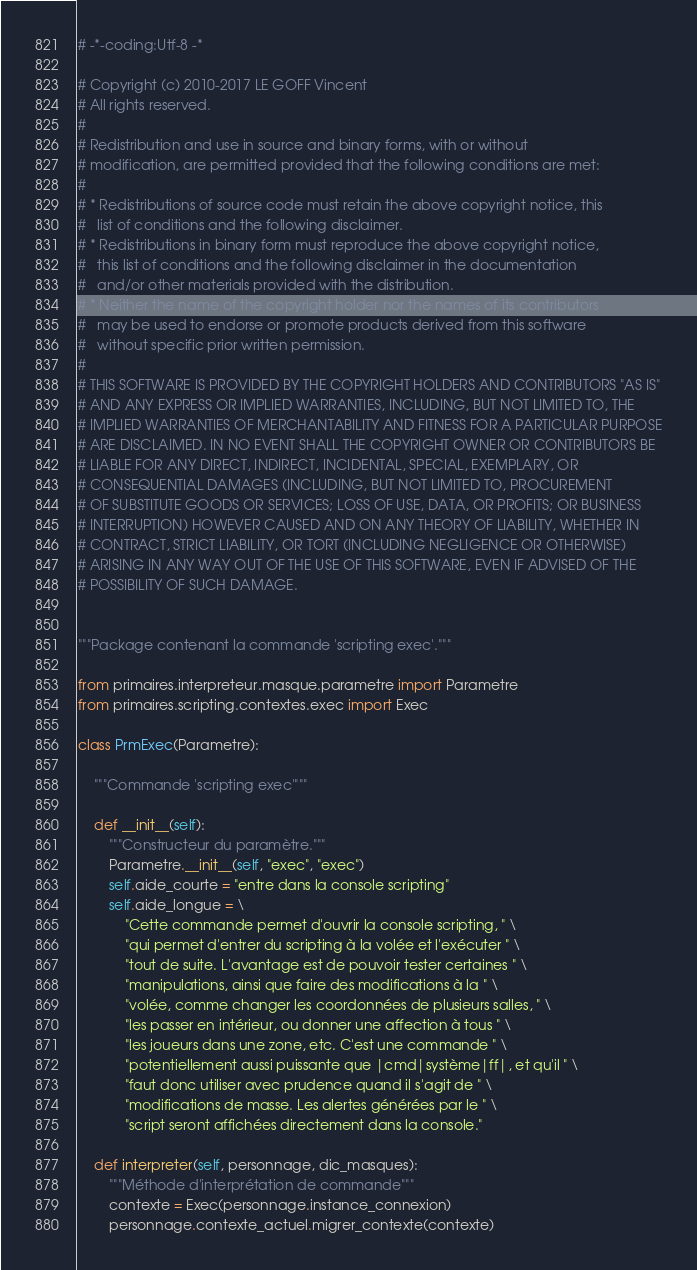<code> <loc_0><loc_0><loc_500><loc_500><_Python_># -*-coding:Utf-8 -*

# Copyright (c) 2010-2017 LE GOFF Vincent
# All rights reserved.
#
# Redistribution and use in source and binary forms, with or without
# modification, are permitted provided that the following conditions are met:
#
# * Redistributions of source code must retain the above copyright notice, this
#   list of conditions and the following disclaimer.
# * Redistributions in binary form must reproduce the above copyright notice,
#   this list of conditions and the following disclaimer in the documentation
#   and/or other materials provided with the distribution.
# * Neither the name of the copyright holder nor the names of its contributors
#   may be used to endorse or promote products derived from this software
#   without specific prior written permission.
#
# THIS SOFTWARE IS PROVIDED BY THE COPYRIGHT HOLDERS AND CONTRIBUTORS "AS IS"
# AND ANY EXPRESS OR IMPLIED WARRANTIES, INCLUDING, BUT NOT LIMITED TO, THE
# IMPLIED WARRANTIES OF MERCHANTABILITY AND FITNESS FOR A PARTICULAR PURPOSE
# ARE DISCLAIMED. IN NO EVENT SHALL THE COPYRIGHT OWNER OR CONTRIBUTORS BE
# LIABLE FOR ANY DIRECT, INDIRECT, INCIDENTAL, SPECIAL, EXEMPLARY, OR
# CONSEQUENTIAL DAMAGES (INCLUDING, BUT NOT LIMITED TO, PROCUREMENT
# OF SUBSTITUTE GOODS OR SERVICES; LOSS OF USE, DATA, OR PROFITS; OR BUSINESS
# INTERRUPTION) HOWEVER CAUSED AND ON ANY THEORY OF LIABILITY, WHETHER IN
# CONTRACT, STRICT LIABILITY, OR TORT (INCLUDING NEGLIGENCE OR OTHERWISE)
# ARISING IN ANY WAY OUT OF THE USE OF THIS SOFTWARE, EVEN IF ADVISED OF THE
# POSSIBILITY OF SUCH DAMAGE.


"""Package contenant la commande 'scripting exec'."""

from primaires.interpreteur.masque.parametre import Parametre
from primaires.scripting.contextes.exec import Exec

class PrmExec(Parametre):

    """Commande 'scripting exec'"""

    def __init__(self):
        """Constructeur du paramètre."""
        Parametre.__init__(self, "exec", "exec")
        self.aide_courte = "entre dans la console scripting"
        self.aide_longue = \
            "Cette commande permet d'ouvrir la console scripting, " \
            "qui permet d'entrer du scripting à la volée et l'exécuter " \
            "tout de suite. L'avantage est de pouvoir tester certaines " \
            "manipulations, ainsi que faire des modifications à la " \
            "volée, comme changer les coordonnées de plusieurs salles, " \
            "les passer en intérieur, ou donner une affection à tous " \
            "les joueurs dans une zone, etc. C'est une commande " \
            "potentiellement aussi puissante que |cmd|système|ff|, et qu'il " \
            "faut donc utiliser avec prudence quand il s'agit de " \
            "modifications de masse. Les alertes générées par le " \
            "script seront affichées directement dans la console."

    def interpreter(self, personnage, dic_masques):
        """Méthode d'interprétation de commande"""
        contexte = Exec(personnage.instance_connexion)
        personnage.contexte_actuel.migrer_contexte(contexte)
</code> 